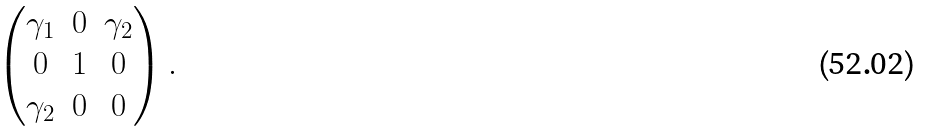Convert formula to latex. <formula><loc_0><loc_0><loc_500><loc_500>\begin{pmatrix} \gamma _ { 1 } & 0 & \gamma _ { 2 } \\ 0 & 1 & 0 \\ \gamma _ { 2 } & 0 & 0 \end{pmatrix} .</formula> 